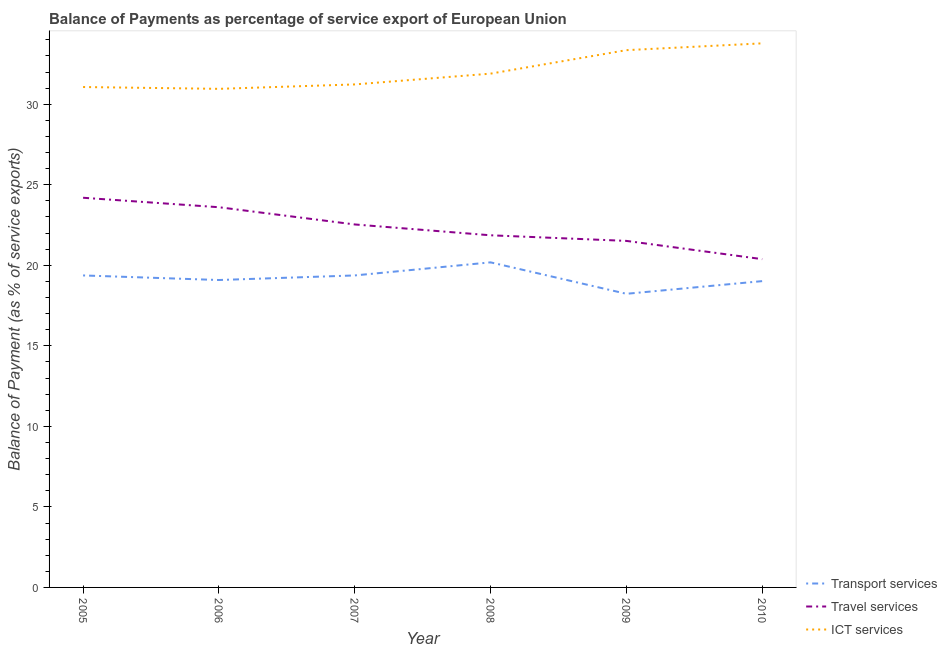How many different coloured lines are there?
Offer a very short reply. 3. Is the number of lines equal to the number of legend labels?
Provide a short and direct response. Yes. What is the balance of payment of transport services in 2009?
Your answer should be very brief. 18.23. Across all years, what is the maximum balance of payment of transport services?
Offer a terse response. 20.18. Across all years, what is the minimum balance of payment of travel services?
Make the answer very short. 20.38. In which year was the balance of payment of travel services minimum?
Make the answer very short. 2010. What is the total balance of payment of ict services in the graph?
Offer a terse response. 192.3. What is the difference between the balance of payment of transport services in 2009 and that in 2010?
Your response must be concise. -0.79. What is the difference between the balance of payment of ict services in 2008 and the balance of payment of travel services in 2007?
Your answer should be compact. 9.36. What is the average balance of payment of ict services per year?
Ensure brevity in your answer.  32.05. In the year 2007, what is the difference between the balance of payment of ict services and balance of payment of travel services?
Your answer should be very brief. 8.69. In how many years, is the balance of payment of travel services greater than 15 %?
Keep it short and to the point. 6. What is the ratio of the balance of payment of ict services in 2008 to that in 2010?
Your answer should be compact. 0.94. Is the balance of payment of travel services in 2005 less than that in 2007?
Ensure brevity in your answer.  No. What is the difference between the highest and the second highest balance of payment of ict services?
Offer a very short reply. 0.42. What is the difference between the highest and the lowest balance of payment of transport services?
Your response must be concise. 1.95. Does the balance of payment of ict services monotonically increase over the years?
Provide a succinct answer. No. Is the balance of payment of travel services strictly greater than the balance of payment of transport services over the years?
Your answer should be very brief. Yes. Is the balance of payment of ict services strictly less than the balance of payment of travel services over the years?
Your response must be concise. No. How many years are there in the graph?
Offer a terse response. 6. What is the difference between two consecutive major ticks on the Y-axis?
Give a very brief answer. 5. Does the graph contain any zero values?
Your response must be concise. No. How many legend labels are there?
Ensure brevity in your answer.  3. How are the legend labels stacked?
Offer a very short reply. Vertical. What is the title of the graph?
Offer a very short reply. Balance of Payments as percentage of service export of European Union. What is the label or title of the X-axis?
Your response must be concise. Year. What is the label or title of the Y-axis?
Provide a short and direct response. Balance of Payment (as % of service exports). What is the Balance of Payment (as % of service exports) in Transport services in 2005?
Give a very brief answer. 19.37. What is the Balance of Payment (as % of service exports) in Travel services in 2005?
Offer a terse response. 24.19. What is the Balance of Payment (as % of service exports) in ICT services in 2005?
Provide a short and direct response. 31.07. What is the Balance of Payment (as % of service exports) in Transport services in 2006?
Provide a short and direct response. 19.09. What is the Balance of Payment (as % of service exports) of Travel services in 2006?
Keep it short and to the point. 23.61. What is the Balance of Payment (as % of service exports) of ICT services in 2006?
Provide a succinct answer. 30.96. What is the Balance of Payment (as % of service exports) of Transport services in 2007?
Provide a succinct answer. 19.37. What is the Balance of Payment (as % of service exports) in Travel services in 2007?
Ensure brevity in your answer.  22.54. What is the Balance of Payment (as % of service exports) of ICT services in 2007?
Offer a terse response. 31.23. What is the Balance of Payment (as % of service exports) in Transport services in 2008?
Provide a succinct answer. 20.18. What is the Balance of Payment (as % of service exports) of Travel services in 2008?
Keep it short and to the point. 21.86. What is the Balance of Payment (as % of service exports) in ICT services in 2008?
Your answer should be very brief. 31.9. What is the Balance of Payment (as % of service exports) in Transport services in 2009?
Offer a very short reply. 18.23. What is the Balance of Payment (as % of service exports) of Travel services in 2009?
Offer a terse response. 21.52. What is the Balance of Payment (as % of service exports) of ICT services in 2009?
Your answer should be compact. 33.36. What is the Balance of Payment (as % of service exports) in Transport services in 2010?
Your answer should be very brief. 19.02. What is the Balance of Payment (as % of service exports) of Travel services in 2010?
Give a very brief answer. 20.38. What is the Balance of Payment (as % of service exports) of ICT services in 2010?
Offer a terse response. 33.78. Across all years, what is the maximum Balance of Payment (as % of service exports) in Transport services?
Offer a very short reply. 20.18. Across all years, what is the maximum Balance of Payment (as % of service exports) of Travel services?
Your answer should be compact. 24.19. Across all years, what is the maximum Balance of Payment (as % of service exports) of ICT services?
Provide a succinct answer. 33.78. Across all years, what is the minimum Balance of Payment (as % of service exports) in Transport services?
Keep it short and to the point. 18.23. Across all years, what is the minimum Balance of Payment (as % of service exports) of Travel services?
Provide a short and direct response. 20.38. Across all years, what is the minimum Balance of Payment (as % of service exports) in ICT services?
Ensure brevity in your answer.  30.96. What is the total Balance of Payment (as % of service exports) of Transport services in the graph?
Keep it short and to the point. 115.26. What is the total Balance of Payment (as % of service exports) of Travel services in the graph?
Your response must be concise. 134.1. What is the total Balance of Payment (as % of service exports) in ICT services in the graph?
Provide a short and direct response. 192.3. What is the difference between the Balance of Payment (as % of service exports) of Transport services in 2005 and that in 2006?
Your response must be concise. 0.28. What is the difference between the Balance of Payment (as % of service exports) in Travel services in 2005 and that in 2006?
Ensure brevity in your answer.  0.59. What is the difference between the Balance of Payment (as % of service exports) in ICT services in 2005 and that in 2006?
Ensure brevity in your answer.  0.11. What is the difference between the Balance of Payment (as % of service exports) in Travel services in 2005 and that in 2007?
Keep it short and to the point. 1.66. What is the difference between the Balance of Payment (as % of service exports) of ICT services in 2005 and that in 2007?
Make the answer very short. -0.16. What is the difference between the Balance of Payment (as % of service exports) of Transport services in 2005 and that in 2008?
Provide a succinct answer. -0.81. What is the difference between the Balance of Payment (as % of service exports) of Travel services in 2005 and that in 2008?
Your answer should be very brief. 2.33. What is the difference between the Balance of Payment (as % of service exports) of ICT services in 2005 and that in 2008?
Offer a terse response. -0.83. What is the difference between the Balance of Payment (as % of service exports) of Transport services in 2005 and that in 2009?
Keep it short and to the point. 1.14. What is the difference between the Balance of Payment (as % of service exports) of Travel services in 2005 and that in 2009?
Give a very brief answer. 2.68. What is the difference between the Balance of Payment (as % of service exports) in ICT services in 2005 and that in 2009?
Your answer should be compact. -2.29. What is the difference between the Balance of Payment (as % of service exports) of Transport services in 2005 and that in 2010?
Offer a very short reply. 0.35. What is the difference between the Balance of Payment (as % of service exports) in Travel services in 2005 and that in 2010?
Provide a short and direct response. 3.81. What is the difference between the Balance of Payment (as % of service exports) in ICT services in 2005 and that in 2010?
Your answer should be very brief. -2.71. What is the difference between the Balance of Payment (as % of service exports) in Transport services in 2006 and that in 2007?
Offer a very short reply. -0.28. What is the difference between the Balance of Payment (as % of service exports) in Travel services in 2006 and that in 2007?
Your answer should be compact. 1.07. What is the difference between the Balance of Payment (as % of service exports) of ICT services in 2006 and that in 2007?
Keep it short and to the point. -0.27. What is the difference between the Balance of Payment (as % of service exports) of Transport services in 2006 and that in 2008?
Your answer should be compact. -1.1. What is the difference between the Balance of Payment (as % of service exports) of Travel services in 2006 and that in 2008?
Provide a succinct answer. 1.74. What is the difference between the Balance of Payment (as % of service exports) in ICT services in 2006 and that in 2008?
Ensure brevity in your answer.  -0.94. What is the difference between the Balance of Payment (as % of service exports) of Transport services in 2006 and that in 2009?
Keep it short and to the point. 0.86. What is the difference between the Balance of Payment (as % of service exports) in Travel services in 2006 and that in 2009?
Your answer should be compact. 2.09. What is the difference between the Balance of Payment (as % of service exports) of ICT services in 2006 and that in 2009?
Make the answer very short. -2.4. What is the difference between the Balance of Payment (as % of service exports) of Transport services in 2006 and that in 2010?
Offer a terse response. 0.07. What is the difference between the Balance of Payment (as % of service exports) in Travel services in 2006 and that in 2010?
Offer a terse response. 3.22. What is the difference between the Balance of Payment (as % of service exports) of ICT services in 2006 and that in 2010?
Offer a very short reply. -2.83. What is the difference between the Balance of Payment (as % of service exports) in Transport services in 2007 and that in 2008?
Make the answer very short. -0.81. What is the difference between the Balance of Payment (as % of service exports) of Travel services in 2007 and that in 2008?
Provide a short and direct response. 0.67. What is the difference between the Balance of Payment (as % of service exports) of ICT services in 2007 and that in 2008?
Offer a very short reply. -0.67. What is the difference between the Balance of Payment (as % of service exports) in Transport services in 2007 and that in 2009?
Ensure brevity in your answer.  1.14. What is the difference between the Balance of Payment (as % of service exports) of Travel services in 2007 and that in 2009?
Give a very brief answer. 1.02. What is the difference between the Balance of Payment (as % of service exports) in ICT services in 2007 and that in 2009?
Your answer should be compact. -2.13. What is the difference between the Balance of Payment (as % of service exports) of Transport services in 2007 and that in 2010?
Offer a very short reply. 0.35. What is the difference between the Balance of Payment (as % of service exports) of Travel services in 2007 and that in 2010?
Make the answer very short. 2.15. What is the difference between the Balance of Payment (as % of service exports) of ICT services in 2007 and that in 2010?
Give a very brief answer. -2.55. What is the difference between the Balance of Payment (as % of service exports) of Transport services in 2008 and that in 2009?
Provide a succinct answer. 1.95. What is the difference between the Balance of Payment (as % of service exports) of Travel services in 2008 and that in 2009?
Provide a short and direct response. 0.35. What is the difference between the Balance of Payment (as % of service exports) in ICT services in 2008 and that in 2009?
Offer a terse response. -1.46. What is the difference between the Balance of Payment (as % of service exports) in Transport services in 2008 and that in 2010?
Make the answer very short. 1.17. What is the difference between the Balance of Payment (as % of service exports) in Travel services in 2008 and that in 2010?
Offer a terse response. 1.48. What is the difference between the Balance of Payment (as % of service exports) in ICT services in 2008 and that in 2010?
Offer a very short reply. -1.88. What is the difference between the Balance of Payment (as % of service exports) in Transport services in 2009 and that in 2010?
Offer a terse response. -0.79. What is the difference between the Balance of Payment (as % of service exports) in Travel services in 2009 and that in 2010?
Provide a succinct answer. 1.13. What is the difference between the Balance of Payment (as % of service exports) in ICT services in 2009 and that in 2010?
Provide a short and direct response. -0.42. What is the difference between the Balance of Payment (as % of service exports) of Transport services in 2005 and the Balance of Payment (as % of service exports) of Travel services in 2006?
Give a very brief answer. -4.24. What is the difference between the Balance of Payment (as % of service exports) in Transport services in 2005 and the Balance of Payment (as % of service exports) in ICT services in 2006?
Ensure brevity in your answer.  -11.59. What is the difference between the Balance of Payment (as % of service exports) of Travel services in 2005 and the Balance of Payment (as % of service exports) of ICT services in 2006?
Give a very brief answer. -6.76. What is the difference between the Balance of Payment (as % of service exports) of Transport services in 2005 and the Balance of Payment (as % of service exports) of Travel services in 2007?
Offer a very short reply. -3.17. What is the difference between the Balance of Payment (as % of service exports) of Transport services in 2005 and the Balance of Payment (as % of service exports) of ICT services in 2007?
Make the answer very short. -11.86. What is the difference between the Balance of Payment (as % of service exports) of Travel services in 2005 and the Balance of Payment (as % of service exports) of ICT services in 2007?
Give a very brief answer. -7.04. What is the difference between the Balance of Payment (as % of service exports) in Transport services in 2005 and the Balance of Payment (as % of service exports) in Travel services in 2008?
Provide a succinct answer. -2.49. What is the difference between the Balance of Payment (as % of service exports) in Transport services in 2005 and the Balance of Payment (as % of service exports) in ICT services in 2008?
Your answer should be compact. -12.53. What is the difference between the Balance of Payment (as % of service exports) in Travel services in 2005 and the Balance of Payment (as % of service exports) in ICT services in 2008?
Ensure brevity in your answer.  -7.71. What is the difference between the Balance of Payment (as % of service exports) in Transport services in 2005 and the Balance of Payment (as % of service exports) in Travel services in 2009?
Your answer should be very brief. -2.14. What is the difference between the Balance of Payment (as % of service exports) in Transport services in 2005 and the Balance of Payment (as % of service exports) in ICT services in 2009?
Keep it short and to the point. -13.99. What is the difference between the Balance of Payment (as % of service exports) in Travel services in 2005 and the Balance of Payment (as % of service exports) in ICT services in 2009?
Keep it short and to the point. -9.16. What is the difference between the Balance of Payment (as % of service exports) of Transport services in 2005 and the Balance of Payment (as % of service exports) of Travel services in 2010?
Your answer should be compact. -1.01. What is the difference between the Balance of Payment (as % of service exports) of Transport services in 2005 and the Balance of Payment (as % of service exports) of ICT services in 2010?
Make the answer very short. -14.41. What is the difference between the Balance of Payment (as % of service exports) in Travel services in 2005 and the Balance of Payment (as % of service exports) in ICT services in 2010?
Offer a very short reply. -9.59. What is the difference between the Balance of Payment (as % of service exports) of Transport services in 2006 and the Balance of Payment (as % of service exports) of Travel services in 2007?
Ensure brevity in your answer.  -3.45. What is the difference between the Balance of Payment (as % of service exports) in Transport services in 2006 and the Balance of Payment (as % of service exports) in ICT services in 2007?
Give a very brief answer. -12.14. What is the difference between the Balance of Payment (as % of service exports) in Travel services in 2006 and the Balance of Payment (as % of service exports) in ICT services in 2007?
Provide a short and direct response. -7.62. What is the difference between the Balance of Payment (as % of service exports) of Transport services in 2006 and the Balance of Payment (as % of service exports) of Travel services in 2008?
Make the answer very short. -2.78. What is the difference between the Balance of Payment (as % of service exports) in Transport services in 2006 and the Balance of Payment (as % of service exports) in ICT services in 2008?
Ensure brevity in your answer.  -12.81. What is the difference between the Balance of Payment (as % of service exports) in Travel services in 2006 and the Balance of Payment (as % of service exports) in ICT services in 2008?
Give a very brief answer. -8.29. What is the difference between the Balance of Payment (as % of service exports) of Transport services in 2006 and the Balance of Payment (as % of service exports) of Travel services in 2009?
Your answer should be compact. -2.43. What is the difference between the Balance of Payment (as % of service exports) in Transport services in 2006 and the Balance of Payment (as % of service exports) in ICT services in 2009?
Your response must be concise. -14.27. What is the difference between the Balance of Payment (as % of service exports) in Travel services in 2006 and the Balance of Payment (as % of service exports) in ICT services in 2009?
Give a very brief answer. -9.75. What is the difference between the Balance of Payment (as % of service exports) of Transport services in 2006 and the Balance of Payment (as % of service exports) of Travel services in 2010?
Provide a short and direct response. -1.3. What is the difference between the Balance of Payment (as % of service exports) of Transport services in 2006 and the Balance of Payment (as % of service exports) of ICT services in 2010?
Provide a succinct answer. -14.69. What is the difference between the Balance of Payment (as % of service exports) in Travel services in 2006 and the Balance of Payment (as % of service exports) in ICT services in 2010?
Offer a terse response. -10.18. What is the difference between the Balance of Payment (as % of service exports) of Transport services in 2007 and the Balance of Payment (as % of service exports) of Travel services in 2008?
Keep it short and to the point. -2.49. What is the difference between the Balance of Payment (as % of service exports) in Transport services in 2007 and the Balance of Payment (as % of service exports) in ICT services in 2008?
Provide a succinct answer. -12.53. What is the difference between the Balance of Payment (as % of service exports) in Travel services in 2007 and the Balance of Payment (as % of service exports) in ICT services in 2008?
Your response must be concise. -9.36. What is the difference between the Balance of Payment (as % of service exports) of Transport services in 2007 and the Balance of Payment (as % of service exports) of Travel services in 2009?
Your answer should be very brief. -2.14. What is the difference between the Balance of Payment (as % of service exports) in Transport services in 2007 and the Balance of Payment (as % of service exports) in ICT services in 2009?
Provide a short and direct response. -13.99. What is the difference between the Balance of Payment (as % of service exports) in Travel services in 2007 and the Balance of Payment (as % of service exports) in ICT services in 2009?
Your response must be concise. -10.82. What is the difference between the Balance of Payment (as % of service exports) of Transport services in 2007 and the Balance of Payment (as % of service exports) of Travel services in 2010?
Give a very brief answer. -1.01. What is the difference between the Balance of Payment (as % of service exports) in Transport services in 2007 and the Balance of Payment (as % of service exports) in ICT services in 2010?
Your answer should be very brief. -14.41. What is the difference between the Balance of Payment (as % of service exports) of Travel services in 2007 and the Balance of Payment (as % of service exports) of ICT services in 2010?
Offer a terse response. -11.24. What is the difference between the Balance of Payment (as % of service exports) of Transport services in 2008 and the Balance of Payment (as % of service exports) of Travel services in 2009?
Your answer should be very brief. -1.33. What is the difference between the Balance of Payment (as % of service exports) of Transport services in 2008 and the Balance of Payment (as % of service exports) of ICT services in 2009?
Keep it short and to the point. -13.18. What is the difference between the Balance of Payment (as % of service exports) of Travel services in 2008 and the Balance of Payment (as % of service exports) of ICT services in 2009?
Keep it short and to the point. -11.49. What is the difference between the Balance of Payment (as % of service exports) in Transport services in 2008 and the Balance of Payment (as % of service exports) in Travel services in 2010?
Your answer should be very brief. -0.2. What is the difference between the Balance of Payment (as % of service exports) in Transport services in 2008 and the Balance of Payment (as % of service exports) in ICT services in 2010?
Give a very brief answer. -13.6. What is the difference between the Balance of Payment (as % of service exports) in Travel services in 2008 and the Balance of Payment (as % of service exports) in ICT services in 2010?
Provide a short and direct response. -11.92. What is the difference between the Balance of Payment (as % of service exports) in Transport services in 2009 and the Balance of Payment (as % of service exports) in Travel services in 2010?
Your response must be concise. -2.15. What is the difference between the Balance of Payment (as % of service exports) of Transport services in 2009 and the Balance of Payment (as % of service exports) of ICT services in 2010?
Your response must be concise. -15.55. What is the difference between the Balance of Payment (as % of service exports) in Travel services in 2009 and the Balance of Payment (as % of service exports) in ICT services in 2010?
Keep it short and to the point. -12.27. What is the average Balance of Payment (as % of service exports) of Transport services per year?
Your answer should be very brief. 19.21. What is the average Balance of Payment (as % of service exports) in Travel services per year?
Give a very brief answer. 22.35. What is the average Balance of Payment (as % of service exports) in ICT services per year?
Your answer should be compact. 32.05. In the year 2005, what is the difference between the Balance of Payment (as % of service exports) of Transport services and Balance of Payment (as % of service exports) of Travel services?
Your answer should be compact. -4.82. In the year 2005, what is the difference between the Balance of Payment (as % of service exports) of Transport services and Balance of Payment (as % of service exports) of ICT services?
Your answer should be very brief. -11.7. In the year 2005, what is the difference between the Balance of Payment (as % of service exports) in Travel services and Balance of Payment (as % of service exports) in ICT services?
Give a very brief answer. -6.88. In the year 2006, what is the difference between the Balance of Payment (as % of service exports) in Transport services and Balance of Payment (as % of service exports) in Travel services?
Make the answer very short. -4.52. In the year 2006, what is the difference between the Balance of Payment (as % of service exports) in Transport services and Balance of Payment (as % of service exports) in ICT services?
Offer a very short reply. -11.87. In the year 2006, what is the difference between the Balance of Payment (as % of service exports) in Travel services and Balance of Payment (as % of service exports) in ICT services?
Make the answer very short. -7.35. In the year 2007, what is the difference between the Balance of Payment (as % of service exports) of Transport services and Balance of Payment (as % of service exports) of Travel services?
Give a very brief answer. -3.17. In the year 2007, what is the difference between the Balance of Payment (as % of service exports) in Transport services and Balance of Payment (as % of service exports) in ICT services?
Your response must be concise. -11.86. In the year 2007, what is the difference between the Balance of Payment (as % of service exports) in Travel services and Balance of Payment (as % of service exports) in ICT services?
Give a very brief answer. -8.69. In the year 2008, what is the difference between the Balance of Payment (as % of service exports) in Transport services and Balance of Payment (as % of service exports) in Travel services?
Give a very brief answer. -1.68. In the year 2008, what is the difference between the Balance of Payment (as % of service exports) of Transport services and Balance of Payment (as % of service exports) of ICT services?
Ensure brevity in your answer.  -11.72. In the year 2008, what is the difference between the Balance of Payment (as % of service exports) of Travel services and Balance of Payment (as % of service exports) of ICT services?
Provide a succinct answer. -10.04. In the year 2009, what is the difference between the Balance of Payment (as % of service exports) of Transport services and Balance of Payment (as % of service exports) of Travel services?
Ensure brevity in your answer.  -3.28. In the year 2009, what is the difference between the Balance of Payment (as % of service exports) of Transport services and Balance of Payment (as % of service exports) of ICT services?
Your answer should be very brief. -15.13. In the year 2009, what is the difference between the Balance of Payment (as % of service exports) of Travel services and Balance of Payment (as % of service exports) of ICT services?
Your response must be concise. -11.84. In the year 2010, what is the difference between the Balance of Payment (as % of service exports) in Transport services and Balance of Payment (as % of service exports) in Travel services?
Provide a short and direct response. -1.36. In the year 2010, what is the difference between the Balance of Payment (as % of service exports) of Transport services and Balance of Payment (as % of service exports) of ICT services?
Offer a very short reply. -14.76. In the year 2010, what is the difference between the Balance of Payment (as % of service exports) in Travel services and Balance of Payment (as % of service exports) in ICT services?
Your answer should be very brief. -13.4. What is the ratio of the Balance of Payment (as % of service exports) in Transport services in 2005 to that in 2006?
Keep it short and to the point. 1.01. What is the ratio of the Balance of Payment (as % of service exports) in Travel services in 2005 to that in 2006?
Give a very brief answer. 1.02. What is the ratio of the Balance of Payment (as % of service exports) in ICT services in 2005 to that in 2006?
Keep it short and to the point. 1. What is the ratio of the Balance of Payment (as % of service exports) in Travel services in 2005 to that in 2007?
Your answer should be very brief. 1.07. What is the ratio of the Balance of Payment (as % of service exports) of Transport services in 2005 to that in 2008?
Ensure brevity in your answer.  0.96. What is the ratio of the Balance of Payment (as % of service exports) in Travel services in 2005 to that in 2008?
Ensure brevity in your answer.  1.11. What is the ratio of the Balance of Payment (as % of service exports) of Travel services in 2005 to that in 2009?
Make the answer very short. 1.12. What is the ratio of the Balance of Payment (as % of service exports) of ICT services in 2005 to that in 2009?
Offer a terse response. 0.93. What is the ratio of the Balance of Payment (as % of service exports) in Transport services in 2005 to that in 2010?
Your answer should be very brief. 1.02. What is the ratio of the Balance of Payment (as % of service exports) in Travel services in 2005 to that in 2010?
Your answer should be very brief. 1.19. What is the ratio of the Balance of Payment (as % of service exports) in ICT services in 2005 to that in 2010?
Offer a very short reply. 0.92. What is the ratio of the Balance of Payment (as % of service exports) in Transport services in 2006 to that in 2007?
Ensure brevity in your answer.  0.99. What is the ratio of the Balance of Payment (as % of service exports) of Travel services in 2006 to that in 2007?
Make the answer very short. 1.05. What is the ratio of the Balance of Payment (as % of service exports) of Transport services in 2006 to that in 2008?
Make the answer very short. 0.95. What is the ratio of the Balance of Payment (as % of service exports) of Travel services in 2006 to that in 2008?
Your answer should be very brief. 1.08. What is the ratio of the Balance of Payment (as % of service exports) in ICT services in 2006 to that in 2008?
Give a very brief answer. 0.97. What is the ratio of the Balance of Payment (as % of service exports) in Transport services in 2006 to that in 2009?
Give a very brief answer. 1.05. What is the ratio of the Balance of Payment (as % of service exports) in Travel services in 2006 to that in 2009?
Your answer should be very brief. 1.1. What is the ratio of the Balance of Payment (as % of service exports) of ICT services in 2006 to that in 2009?
Ensure brevity in your answer.  0.93. What is the ratio of the Balance of Payment (as % of service exports) in Transport services in 2006 to that in 2010?
Your response must be concise. 1. What is the ratio of the Balance of Payment (as % of service exports) in Travel services in 2006 to that in 2010?
Ensure brevity in your answer.  1.16. What is the ratio of the Balance of Payment (as % of service exports) in ICT services in 2006 to that in 2010?
Keep it short and to the point. 0.92. What is the ratio of the Balance of Payment (as % of service exports) of Transport services in 2007 to that in 2008?
Provide a succinct answer. 0.96. What is the ratio of the Balance of Payment (as % of service exports) in Travel services in 2007 to that in 2008?
Ensure brevity in your answer.  1.03. What is the ratio of the Balance of Payment (as % of service exports) in Transport services in 2007 to that in 2009?
Your answer should be compact. 1.06. What is the ratio of the Balance of Payment (as % of service exports) in Travel services in 2007 to that in 2009?
Provide a short and direct response. 1.05. What is the ratio of the Balance of Payment (as % of service exports) of ICT services in 2007 to that in 2009?
Your response must be concise. 0.94. What is the ratio of the Balance of Payment (as % of service exports) of Transport services in 2007 to that in 2010?
Keep it short and to the point. 1.02. What is the ratio of the Balance of Payment (as % of service exports) in Travel services in 2007 to that in 2010?
Your answer should be compact. 1.11. What is the ratio of the Balance of Payment (as % of service exports) in ICT services in 2007 to that in 2010?
Offer a terse response. 0.92. What is the ratio of the Balance of Payment (as % of service exports) in Transport services in 2008 to that in 2009?
Keep it short and to the point. 1.11. What is the ratio of the Balance of Payment (as % of service exports) in Travel services in 2008 to that in 2009?
Provide a succinct answer. 1.02. What is the ratio of the Balance of Payment (as % of service exports) of ICT services in 2008 to that in 2009?
Make the answer very short. 0.96. What is the ratio of the Balance of Payment (as % of service exports) of Transport services in 2008 to that in 2010?
Ensure brevity in your answer.  1.06. What is the ratio of the Balance of Payment (as % of service exports) of Travel services in 2008 to that in 2010?
Your answer should be very brief. 1.07. What is the ratio of the Balance of Payment (as % of service exports) in ICT services in 2008 to that in 2010?
Make the answer very short. 0.94. What is the ratio of the Balance of Payment (as % of service exports) of Transport services in 2009 to that in 2010?
Give a very brief answer. 0.96. What is the ratio of the Balance of Payment (as % of service exports) in Travel services in 2009 to that in 2010?
Provide a succinct answer. 1.06. What is the ratio of the Balance of Payment (as % of service exports) in ICT services in 2009 to that in 2010?
Provide a succinct answer. 0.99. What is the difference between the highest and the second highest Balance of Payment (as % of service exports) in Transport services?
Make the answer very short. 0.81. What is the difference between the highest and the second highest Balance of Payment (as % of service exports) in Travel services?
Give a very brief answer. 0.59. What is the difference between the highest and the second highest Balance of Payment (as % of service exports) of ICT services?
Your answer should be very brief. 0.42. What is the difference between the highest and the lowest Balance of Payment (as % of service exports) in Transport services?
Offer a terse response. 1.95. What is the difference between the highest and the lowest Balance of Payment (as % of service exports) in Travel services?
Offer a very short reply. 3.81. What is the difference between the highest and the lowest Balance of Payment (as % of service exports) of ICT services?
Make the answer very short. 2.83. 